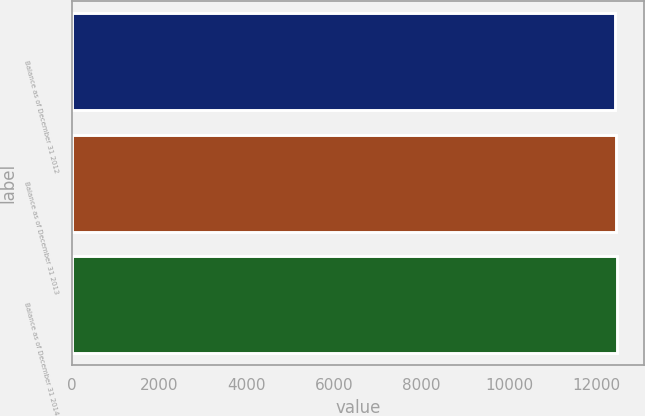Convert chart. <chart><loc_0><loc_0><loc_500><loc_500><bar_chart><fcel>Balance as of December 31 2012<fcel>Balance as of December 31 2013<fcel>Balance as of December 31 2014<nl><fcel>12431<fcel>12438<fcel>12466<nl></chart> 